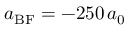Convert formula to latex. <formula><loc_0><loc_0><loc_500><loc_500>a _ { B F } = - 2 5 0 \, a _ { 0 }</formula> 